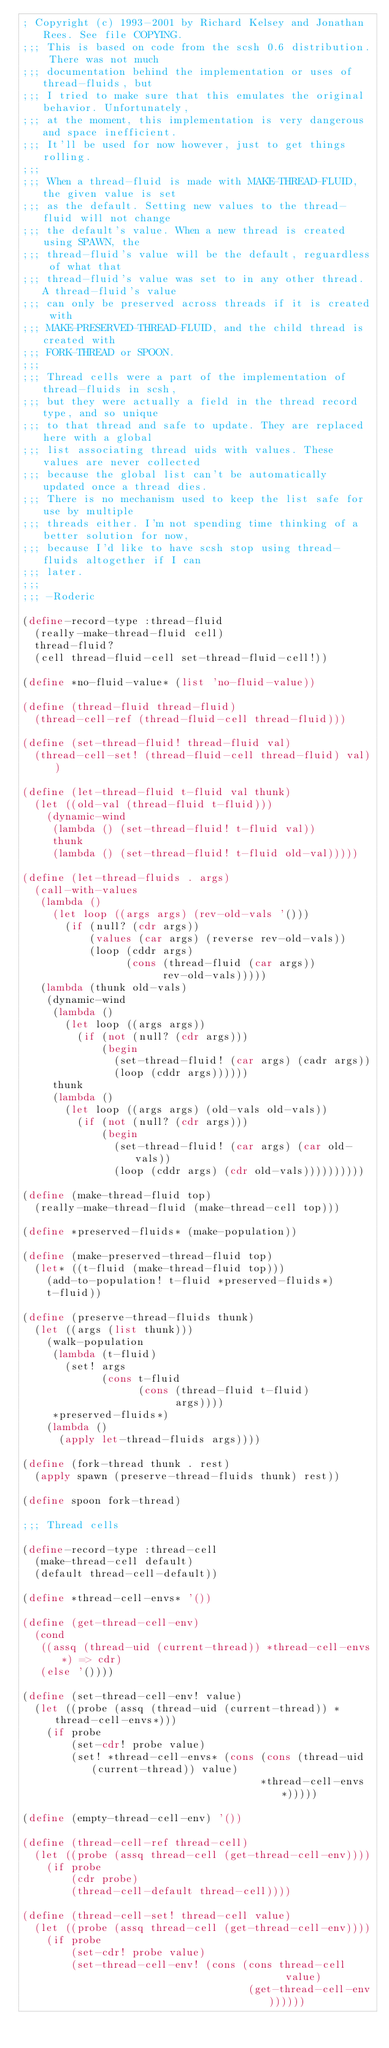Convert code to text. <code><loc_0><loc_0><loc_500><loc_500><_Scheme_>; Copyright (c) 1993-2001 by Richard Kelsey and Jonathan Rees. See file COPYING.
;;; This is based on code from the scsh 0.6 distribution. There was not much
;;; documentation behind the implementation or uses of thread-fluids, but
;;; I tried to make sure that this emulates the original behavior. Unfortunately,
;;; at the moment, this implementation is very dangerous and space inefficient.
;;; It'll be used for now however, just to get things rolling.
;;;
;;; When a thread-fluid is made with MAKE-THREAD-FLUID, the given value is set
;;; as the default. Setting new values to the thread-fluid will not change
;;; the default's value. When a new thread is created using SPAWN, the
;;; thread-fluid's value will be the default, reguardless of what that
;;; thread-fluid's value was set to in any other thread. A thread-fluid's value
;;; can only be preserved across threads if it is created with
;;; MAKE-PRESERVED-THREAD-FLUID, and the child thread is created with
;;; FORK-THREAD or SPOON.
;;;
;;; Thread cells were a part of the implementation of thread-fluids in scsh,
;;; but they were actually a field in the thread record type, and so unique
;;; to that thread and safe to update. They are replaced here with a global
;;; list associating thread uids with values. These values are never collected
;;; because the global list can't be automatically updated once a thread dies.
;;; There is no mechanism used to keep the list safe for use by multiple
;;; threads either. I'm not spending time thinking of a better solution for now,
;;; because I'd like to have scsh stop using thread-fluids altogether if I can
;;; later.
;;;
;;; -Roderic

(define-record-type :thread-fluid
  (really-make-thread-fluid cell)
  thread-fluid?
  (cell thread-fluid-cell set-thread-fluid-cell!))

(define *no-fluid-value* (list 'no-fluid-value))

(define (thread-fluid thread-fluid)
  (thread-cell-ref (thread-fluid-cell thread-fluid)))

(define (set-thread-fluid! thread-fluid val)
  (thread-cell-set! (thread-fluid-cell thread-fluid) val))

(define (let-thread-fluid t-fluid val thunk)
  (let ((old-val (thread-fluid t-fluid)))
    (dynamic-wind
     (lambda () (set-thread-fluid! t-fluid val))
     thunk
     (lambda () (set-thread-fluid! t-fluid old-val)))))

(define (let-thread-fluids . args)
  (call-with-values
   (lambda ()
     (let loop ((args args) (rev-old-vals '()))
       (if (null? (cdr args))
           (values (car args) (reverse rev-old-vals))
           (loop (cddr args)
                 (cons (thread-fluid (car args))
                       rev-old-vals)))))
   (lambda (thunk old-vals)
    (dynamic-wind
     (lambda ()
       (let loop ((args args))
         (if (not (null? (cdr args)))
             (begin
               (set-thread-fluid! (car args) (cadr args))
               (loop (cddr args))))))
     thunk
     (lambda ()
       (let loop ((args args) (old-vals old-vals))
         (if (not (null? (cdr args)))
             (begin
               (set-thread-fluid! (car args) (car old-vals))
               (loop (cddr args) (cdr old-vals))))))))))

(define (make-thread-fluid top)
  (really-make-thread-fluid (make-thread-cell top)))

(define *preserved-fluids* (make-population))

(define (make-preserved-thread-fluid top)
  (let* ((t-fluid (make-thread-fluid top)))
    (add-to-population! t-fluid *preserved-fluids*)
    t-fluid))

(define (preserve-thread-fluids thunk)
  (let ((args (list thunk)))
    (walk-population
     (lambda (t-fluid)
       (set! args
             (cons t-fluid
                   (cons (thread-fluid t-fluid)
                         args))))
     *preserved-fluids*)
    (lambda ()
      (apply let-thread-fluids args))))

(define (fork-thread thunk . rest)
  (apply spawn (preserve-thread-fluids thunk) rest))

(define spoon fork-thread)

;;; Thread cells

(define-record-type :thread-cell
  (make-thread-cell default)
  (default thread-cell-default))

(define *thread-cell-envs* '())

(define (get-thread-cell-env)
  (cond
   ((assq (thread-uid (current-thread)) *thread-cell-envs*) => cdr)
   (else '())))

(define (set-thread-cell-env! value)
  (let ((probe (assq (thread-uid (current-thread)) *thread-cell-envs*)))
    (if probe
        (set-cdr! probe value)
        (set! *thread-cell-envs* (cons (cons (thread-uid (current-thread)) value)
                                       *thread-cell-envs*)))))

(define (empty-thread-cell-env) '())

(define (thread-cell-ref thread-cell)
  (let ((probe (assq thread-cell (get-thread-cell-env))))
    (if probe
        (cdr probe)
        (thread-cell-default thread-cell))))

(define (thread-cell-set! thread-cell value)
  (let ((probe (assq thread-cell (get-thread-cell-env))))
    (if probe
        (set-cdr! probe value)
        (set-thread-cell-env! (cons (cons thread-cell
                                           value)
                                     (get-thread-cell-env))))))
</code> 